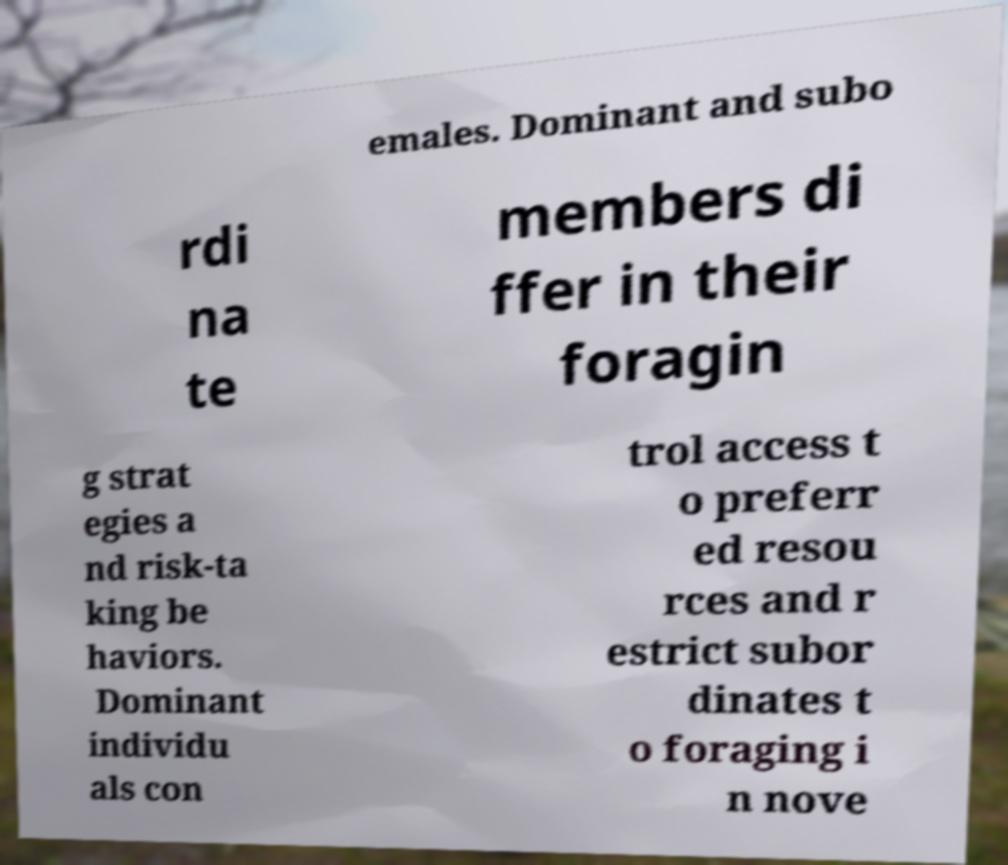Could you extract and type out the text from this image? emales. Dominant and subo rdi na te members di ffer in their foragin g strat egies a nd risk-ta king be haviors. Dominant individu als con trol access t o preferr ed resou rces and r estrict subor dinates t o foraging i n nove 